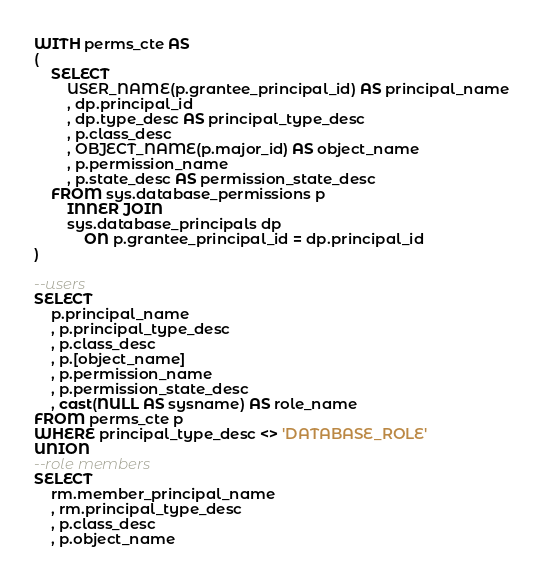Convert code to text. <code><loc_0><loc_0><loc_500><loc_500><_SQL_>WITH perms_cte AS
(
    SELECT
        USER_NAME(p.grantee_principal_id) AS principal_name
        , dp.principal_id
        , dp.type_desc AS principal_type_desc
        , p.class_desc
        , OBJECT_NAME(p.major_id) AS object_name
        , p.permission_name
        , p.state_desc AS permission_state_desc
    FROM sys.database_permissions p
        INNER JOIN
        sys.database_principals dp
            ON p.grantee_principal_id = dp.principal_id
)

--users
SELECT
    p.principal_name
    , p.principal_type_desc
    , p.class_desc
    , p.[object_name]
    , p.permission_name
    , p.permission_state_desc
    , cast(NULL AS sysname) AS role_name
FROM perms_cte p
WHERE principal_type_desc <> 'DATABASE_ROLE'
UNION
--role members
SELECT
    rm.member_principal_name
    , rm.principal_type_desc
    , p.class_desc
    , p.object_name</code> 